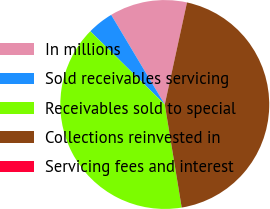<chart> <loc_0><loc_0><loc_500><loc_500><pie_chart><fcel>In millions<fcel>Sold receivables servicing<fcel>Receivables sold to special<fcel>Collections reinvested in<fcel>Servicing fees and interest<nl><fcel>11.98%<fcel>4.06%<fcel>39.95%<fcel>44.0%<fcel>0.01%<nl></chart> 